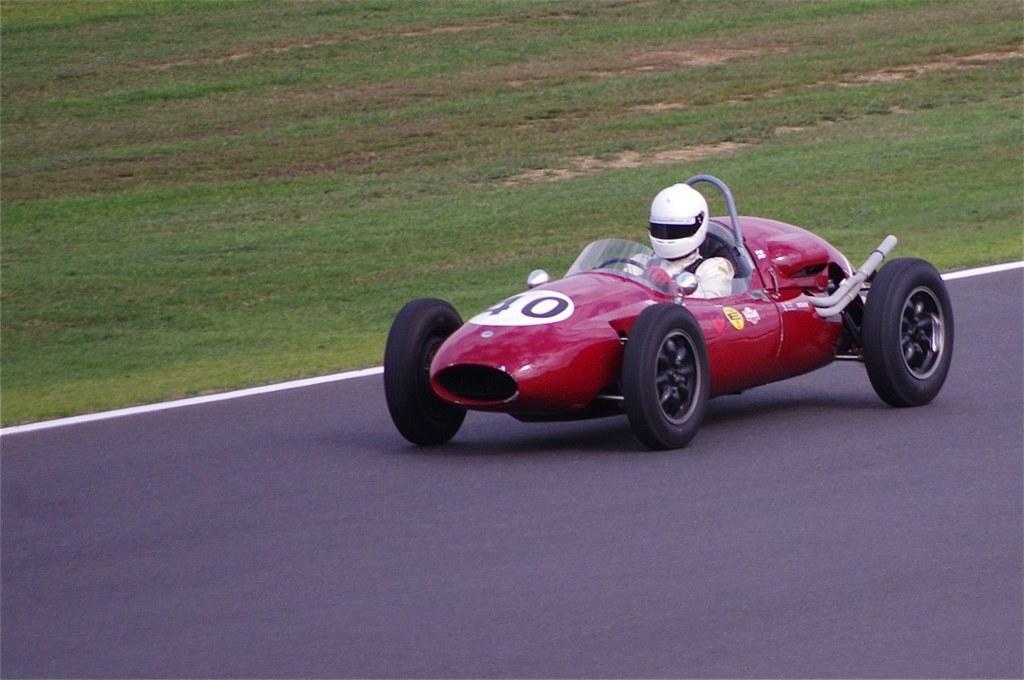Can you describe this image briefly? In this image I can see a red color car and person is sitting inside and wearing a white helmet. The car is on the road. 